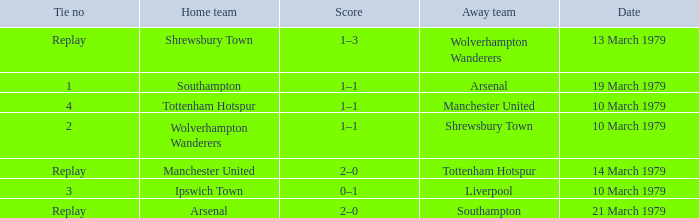Which tie number had an away team of Arsenal? 1.0. 